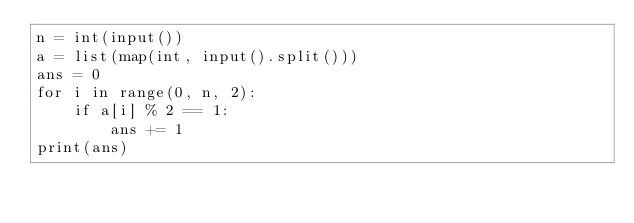<code> <loc_0><loc_0><loc_500><loc_500><_Python_>n = int(input())
a = list(map(int, input().split()))
ans = 0
for i in range(0, n, 2):
    if a[i] % 2 == 1:
        ans += 1
print(ans)</code> 